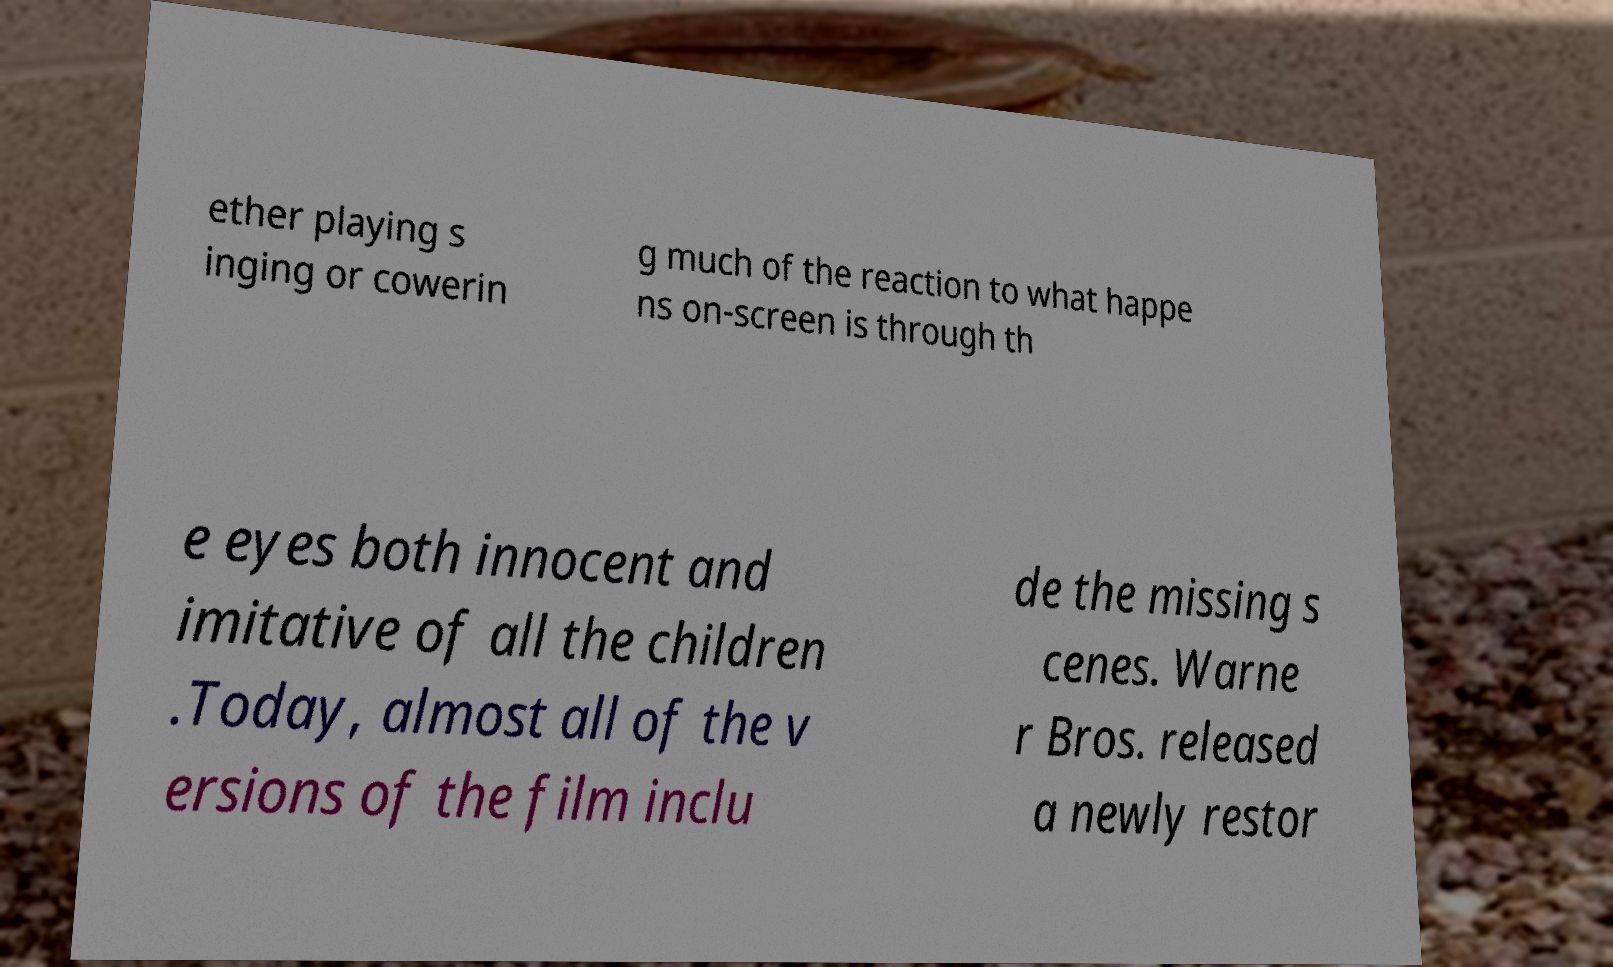Could you assist in decoding the text presented in this image and type it out clearly? ether playing s inging or cowerin g much of the reaction to what happe ns on-screen is through th e eyes both innocent and imitative of all the children .Today, almost all of the v ersions of the film inclu de the missing s cenes. Warne r Bros. released a newly restor 